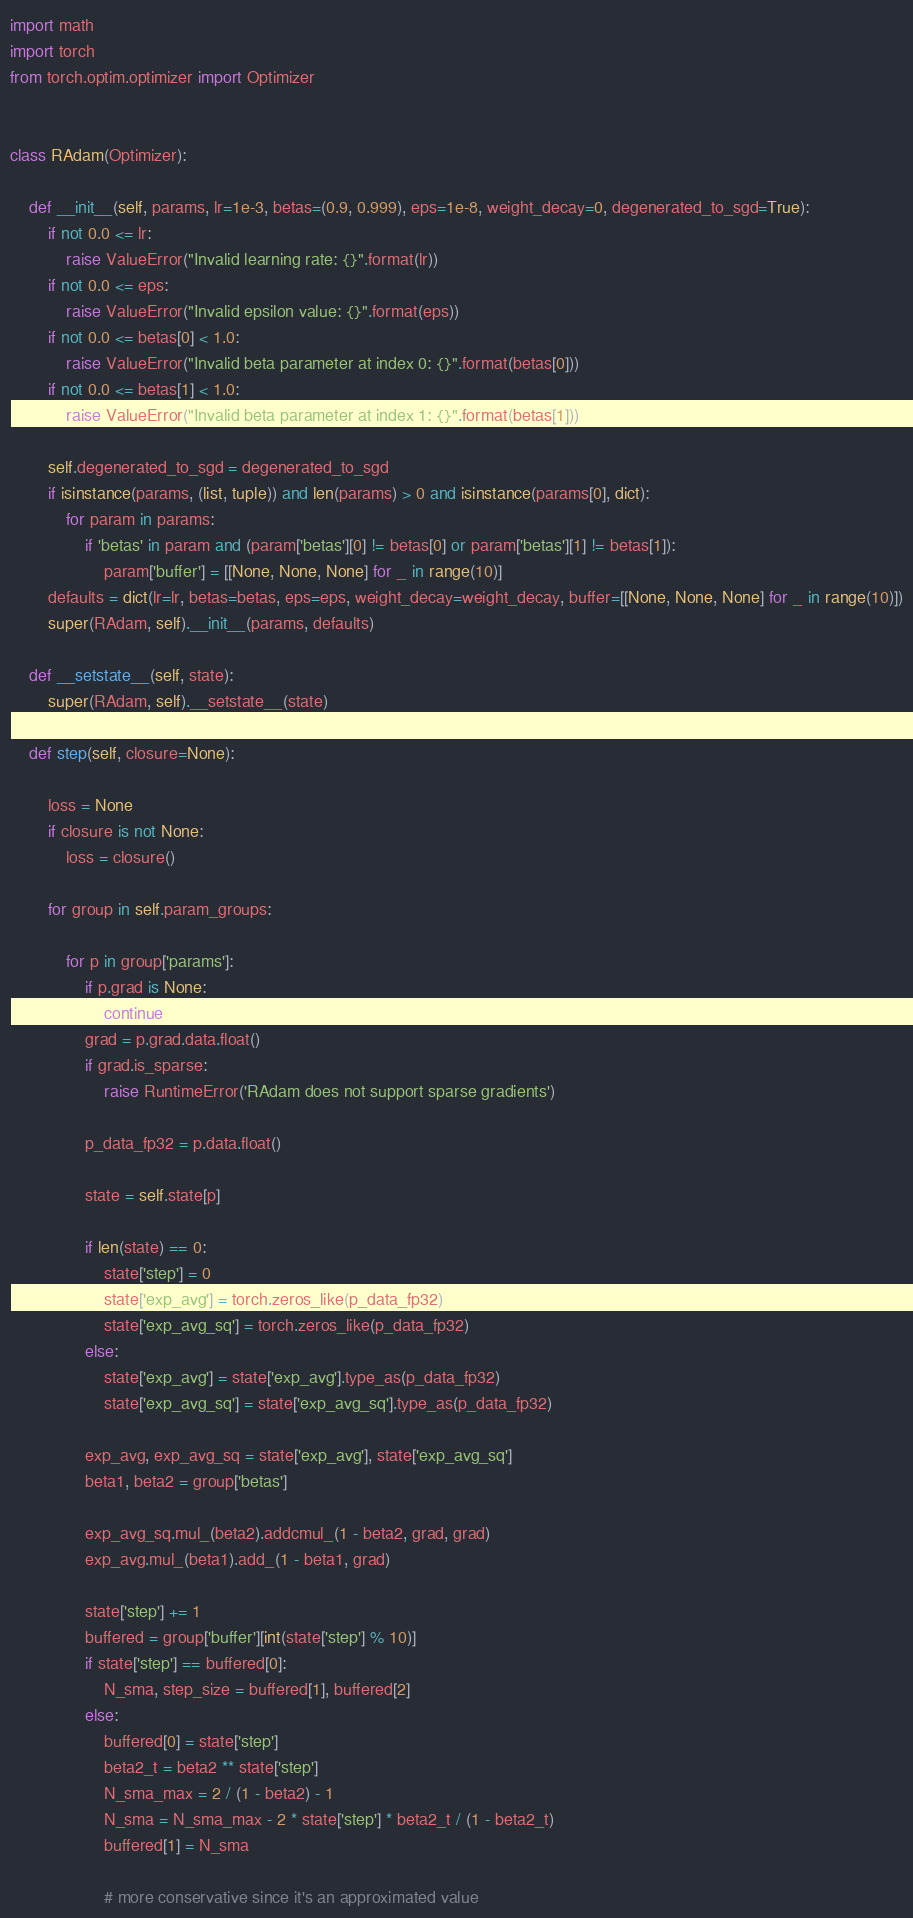Convert code to text. <code><loc_0><loc_0><loc_500><loc_500><_Python_>import math
import torch
from torch.optim.optimizer import Optimizer


class RAdam(Optimizer):

    def __init__(self, params, lr=1e-3, betas=(0.9, 0.999), eps=1e-8, weight_decay=0, degenerated_to_sgd=True):
        if not 0.0 <= lr:
            raise ValueError("Invalid learning rate: {}".format(lr))
        if not 0.0 <= eps:
            raise ValueError("Invalid epsilon value: {}".format(eps))
        if not 0.0 <= betas[0] < 1.0:
            raise ValueError("Invalid beta parameter at index 0: {}".format(betas[0]))
        if not 0.0 <= betas[1] < 1.0:
            raise ValueError("Invalid beta parameter at index 1: {}".format(betas[1]))
        
        self.degenerated_to_sgd = degenerated_to_sgd
        if isinstance(params, (list, tuple)) and len(params) > 0 and isinstance(params[0], dict):
            for param in params:
                if 'betas' in param and (param['betas'][0] != betas[0] or param['betas'][1] != betas[1]):
                    param['buffer'] = [[None, None, None] for _ in range(10)]
        defaults = dict(lr=lr, betas=betas, eps=eps, weight_decay=weight_decay, buffer=[[None, None, None] for _ in range(10)])
        super(RAdam, self).__init__(params, defaults)

    def __setstate__(self, state):
        super(RAdam, self).__setstate__(state)

    def step(self, closure=None):

        loss = None
        if closure is not None:
            loss = closure()

        for group in self.param_groups:

            for p in group['params']:
                if p.grad is None:
                    continue
                grad = p.grad.data.float()
                if grad.is_sparse:
                    raise RuntimeError('RAdam does not support sparse gradients')

                p_data_fp32 = p.data.float()

                state = self.state[p]

                if len(state) == 0:
                    state['step'] = 0
                    state['exp_avg'] = torch.zeros_like(p_data_fp32)
                    state['exp_avg_sq'] = torch.zeros_like(p_data_fp32)
                else:
                    state['exp_avg'] = state['exp_avg'].type_as(p_data_fp32)
                    state['exp_avg_sq'] = state['exp_avg_sq'].type_as(p_data_fp32)

                exp_avg, exp_avg_sq = state['exp_avg'], state['exp_avg_sq']
                beta1, beta2 = group['betas']

                exp_avg_sq.mul_(beta2).addcmul_(1 - beta2, grad, grad)
                exp_avg.mul_(beta1).add_(1 - beta1, grad)

                state['step'] += 1
                buffered = group['buffer'][int(state['step'] % 10)]
                if state['step'] == buffered[0]:
                    N_sma, step_size = buffered[1], buffered[2]
                else:
                    buffered[0] = state['step']
                    beta2_t = beta2 ** state['step']
                    N_sma_max = 2 / (1 - beta2) - 1
                    N_sma = N_sma_max - 2 * state['step'] * beta2_t / (1 - beta2_t)
                    buffered[1] = N_sma

                    # more conservative since it's an approximated value</code> 